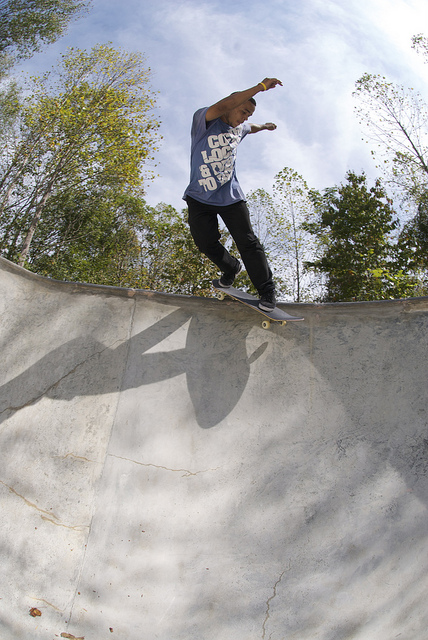Identify the text contained in this image. CO LOCK TO 